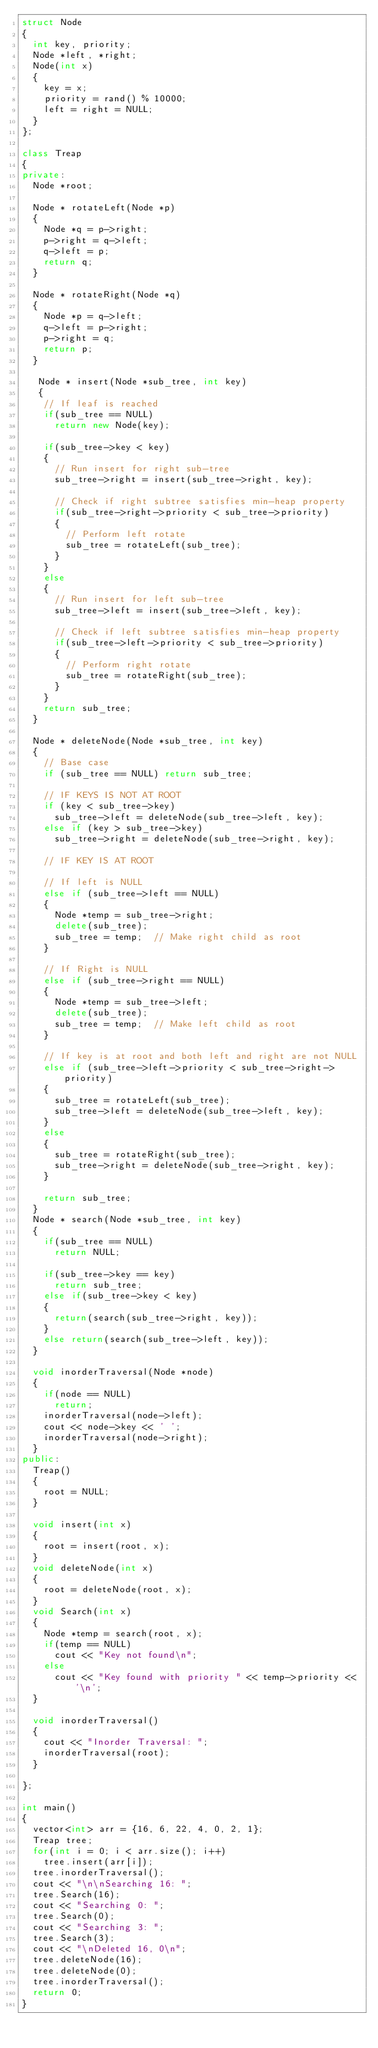<code> <loc_0><loc_0><loc_500><loc_500><_C++_>struct Node
{
	int key, priority;
	Node *left, *right;
	Node(int x)
	{
		key = x;
		priority = rand() % 10000;
		left = right = NULL;
	}
};

class Treap
{
private:
	Node *root;

	Node * rotateLeft(Node *p)
	{
		Node *q = p->right;
		p->right = q->left;
		q->left = p;
		return q;
	}

	Node * rotateRight(Node *q)
	{
		Node *p = q->left;
		q->left = p->right;
		p->right = q;
		return p;
	}

	 Node * insert(Node *sub_tree, int key)
	 {
		// If leaf is reached
		if(sub_tree == NULL)
			return new Node(key);
		
		if(sub_tree->key < key)
		{
			// Run insert for right sub-tree
			sub_tree->right = insert(sub_tree->right, key);

			// Check if right subtree satisfies min-heap property
			if(sub_tree->right->priority < sub_tree->priority)
			{
				// Perform left rotate
				sub_tree = rotateLeft(sub_tree);
			}
		}
		else
		{
			// Run insert for left sub-tree
			sub_tree->left = insert(sub_tree->left, key);

			// Check if left subtree satisfies min-heap property
			if(sub_tree->left->priority < sub_tree->priority)
			{
				// Perform right rotate
				sub_tree = rotateRight(sub_tree);
			}
		}
		return sub_tree;
	}

	Node * deleteNode(Node *sub_tree, int key)
	{
		// Base case
		if (sub_tree == NULL) return sub_tree;
	
		// IF KEYS IS NOT AT ROOT
		if (key < sub_tree->key)
			sub_tree->left = deleteNode(sub_tree->left, key);
		else if (key > sub_tree->key)
			sub_tree->right = deleteNode(sub_tree->right, key);
	 
		// IF KEY IS AT ROOT
	 
		// If left is NULL
		else if (sub_tree->left == NULL)
		{
			Node *temp = sub_tree->right;
			delete(sub_tree);
			sub_tree = temp;  // Make right child as root
		}
	 
		// If Right is NULL
		else if (sub_tree->right == NULL)
		{
			Node *temp = sub_tree->left;
			delete(sub_tree);
			sub_tree = temp;  // Make left child as root
		}
	 
		// If key is at root and both left and right are not NULL
		else if (sub_tree->left->priority < sub_tree->right->priority)
		{
			sub_tree = rotateLeft(sub_tree);
			sub_tree->left = deleteNode(sub_tree->left, key);
		}
		else
		{
			sub_tree = rotateRight(sub_tree);
			sub_tree->right = deleteNode(sub_tree->right, key);
		}
	 
		return sub_tree;
	}
	Node * search(Node *sub_tree, int key)
	{
		if(sub_tree == NULL)
			return NULL;
		
		if(sub_tree->key == key)
			return sub_tree;
		else if(sub_tree->key < key)
		{
			return(search(sub_tree->right, key));
		}
		else return(search(sub_tree->left, key));
	}

	void inorderTraversal(Node *node)
	{
		if(node == NULL)
			return;
		inorderTraversal(node->left);
		cout << node->key << ' ';
		inorderTraversal(node->right);
	}
public:
	Treap()
	{
		root = NULL;
	}

	void insert(int x)
	{
		root = insert(root, x);
	}
	void deleteNode(int x)
	{
		root = deleteNode(root, x);
	}
	void Search(int x)
	{
		Node *temp = search(root, x);
		if(temp == NULL)
			cout << "Key not found\n";
		else
			cout << "Key found with priority " << temp->priority << '\n';
	}

	void inorderTraversal()
	{
		cout << "Inorder Traversal: ";
		inorderTraversal(root);
	}
	
};

int main()
{
	vector<int> arr = {16, 6, 22, 4, 0, 2, 1};
	Treap tree;
	for(int i = 0; i < arr.size(); i++)
		tree.insert(arr[i]);
	tree.inorderTraversal();
	cout << "\n\nSearching 16: ";
	tree.Search(16);
	cout << "Searching 0: ";
	tree.Search(0);
	cout << "Searching 3: ";
	tree.Search(3);
	cout << "\nDeleted 16, 0\n";
	tree.deleteNode(16);
	tree.deleteNode(0);
	tree.inorderTraversal();
	return 0;
}</code> 